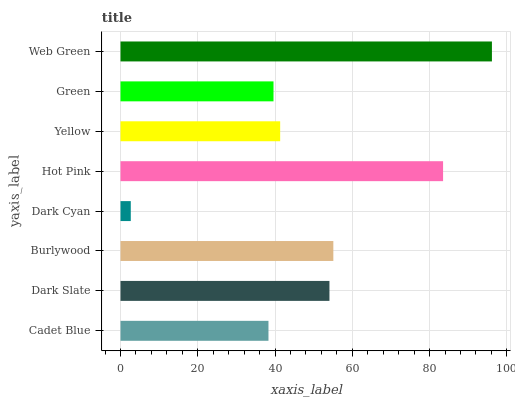Is Dark Cyan the minimum?
Answer yes or no. Yes. Is Web Green the maximum?
Answer yes or no. Yes. Is Dark Slate the minimum?
Answer yes or no. No. Is Dark Slate the maximum?
Answer yes or no. No. Is Dark Slate greater than Cadet Blue?
Answer yes or no. Yes. Is Cadet Blue less than Dark Slate?
Answer yes or no. Yes. Is Cadet Blue greater than Dark Slate?
Answer yes or no. No. Is Dark Slate less than Cadet Blue?
Answer yes or no. No. Is Dark Slate the high median?
Answer yes or no. Yes. Is Yellow the low median?
Answer yes or no. Yes. Is Dark Cyan the high median?
Answer yes or no. No. Is Green the low median?
Answer yes or no. No. 